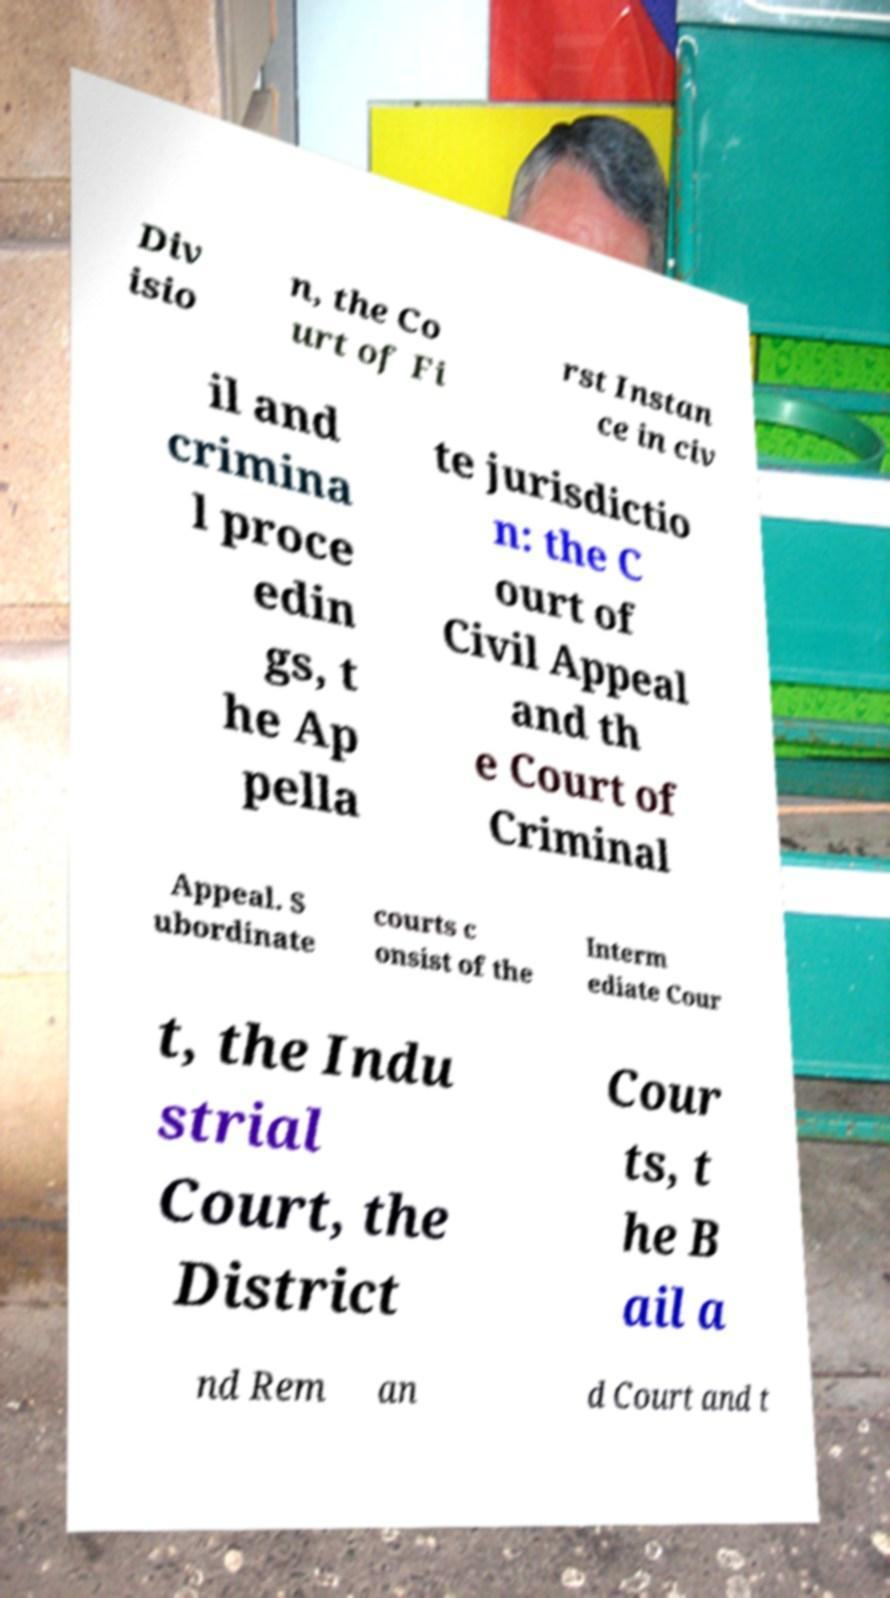What messages or text are displayed in this image? I need them in a readable, typed format. Div isio n, the Co urt of Fi rst Instan ce in civ il and crimina l proce edin gs, t he Ap pella te jurisdictio n: the C ourt of Civil Appeal and th e Court of Criminal Appeal. S ubordinate courts c onsist of the Interm ediate Cour t, the Indu strial Court, the District Cour ts, t he B ail a nd Rem an d Court and t 